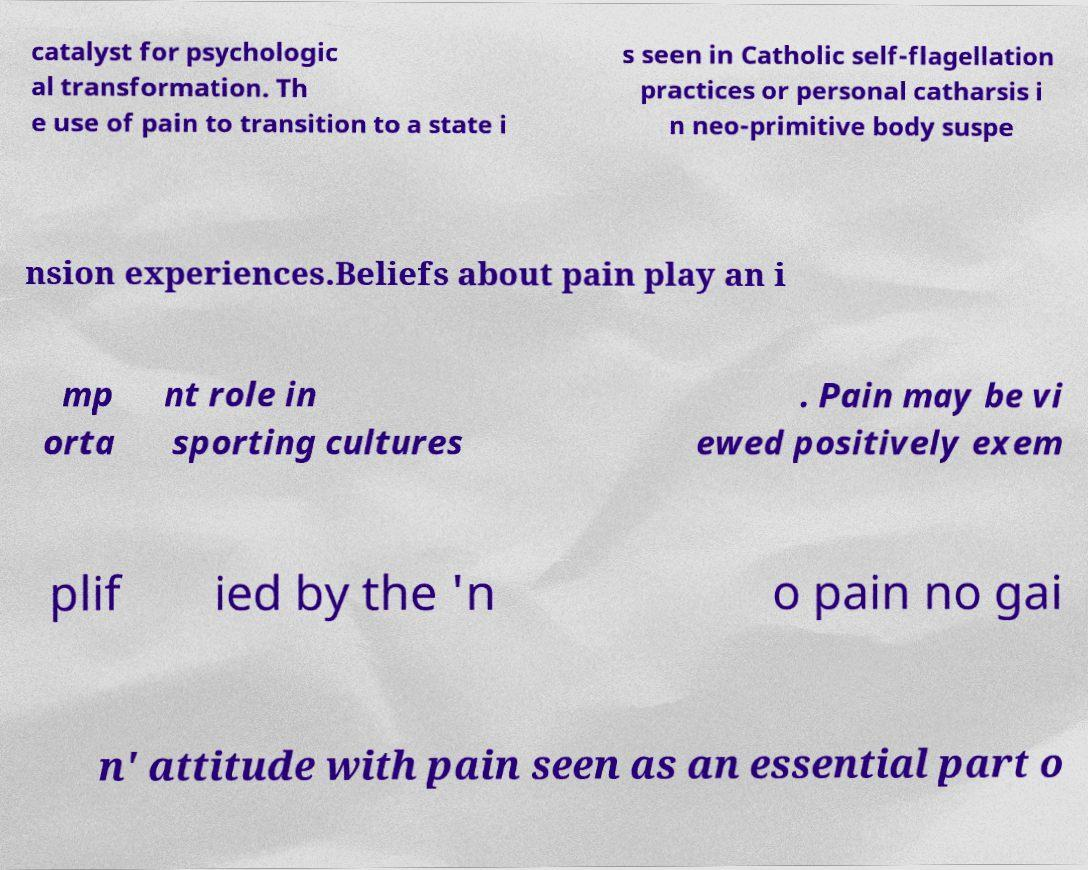Can you read and provide the text displayed in the image?This photo seems to have some interesting text. Can you extract and type it out for me? catalyst for psychologic al transformation. Th e use of pain to transition to a state i s seen in Catholic self-flagellation practices or personal catharsis i n neo-primitive body suspe nsion experiences.Beliefs about pain play an i mp orta nt role in sporting cultures . Pain may be vi ewed positively exem plif ied by the 'n o pain no gai n' attitude with pain seen as an essential part o 